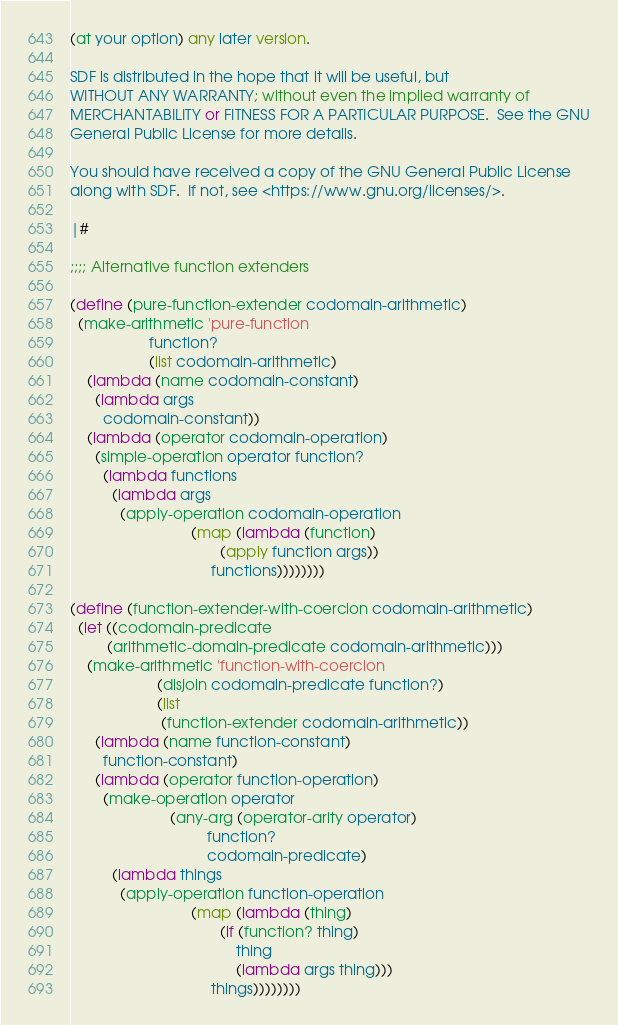Convert code to text. <code><loc_0><loc_0><loc_500><loc_500><_Scheme_>(at your option) any later version.

SDF is distributed in the hope that it will be useful, but
WITHOUT ANY WARRANTY; without even the implied warranty of
MERCHANTABILITY or FITNESS FOR A PARTICULAR PURPOSE.  See the GNU
General Public License for more details.

You should have received a copy of the GNU General Public License
along with SDF.  If not, see <https://www.gnu.org/licenses/>.

|#

;;;; Alternative function extenders

(define (pure-function-extender codomain-arithmetic)
  (make-arithmetic 'pure-function
                   function?
                   (list codomain-arithmetic)
    (lambda (name codomain-constant)
      (lambda args
        codomain-constant))
    (lambda (operator codomain-operation)
      (simple-operation operator function?
        (lambda functions
          (lambda args
            (apply-operation codomain-operation
                             (map (lambda (function)
                                    (apply function args))
                                  functions))))))))

(define (function-extender-with-coercion codomain-arithmetic)
  (let ((codomain-predicate
         (arithmetic-domain-predicate codomain-arithmetic)))
    (make-arithmetic 'function-with-coercion
                     (disjoin codomain-predicate function?)
                     (list
                      (function-extender codomain-arithmetic))
      (lambda (name function-constant)
        function-constant)
      (lambda (operator function-operation)
        (make-operation operator
                        (any-arg (operator-arity operator)
                                 function?
                                 codomain-predicate)
          (lambda things
            (apply-operation function-operation
                             (map (lambda (thing)
                                    (if (function? thing)
                                        thing
                                        (lambda args thing)))
                                  things))))))))
</code> 